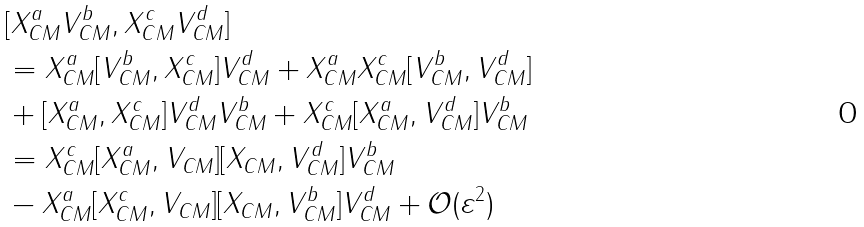Convert formula to latex. <formula><loc_0><loc_0><loc_500><loc_500>& [ X _ { C M } ^ { a } V _ { C M } ^ { b } , X _ { C M } ^ { c } V _ { C M } ^ { d } ] \\ & = X _ { C M } ^ { a } [ V _ { C M } ^ { b } , X _ { C M } ^ { c } ] V _ { C M } ^ { d } + X _ { C M } ^ { a } X _ { C M } ^ { c } [ V _ { C M } ^ { b } , V _ { C M } ^ { d } ] \\ & + [ X _ { C M } ^ { a } , X _ { C M } ^ { c } ] V _ { C M } ^ { d } V _ { C M } ^ { b } + X _ { C M } ^ { c } [ X _ { C M } ^ { a } , V _ { C M } ^ { d } ] V _ { C M } ^ { b } \\ & = X _ { C M } ^ { c } [ X _ { C M } ^ { a } , V _ { C M } ] [ X _ { C M } , V _ { C M } ^ { d } ] V _ { C M } ^ { b } \\ & - X _ { C M } ^ { a } [ X _ { C M } ^ { c } , V _ { C M } ] [ X _ { C M } , V _ { C M } ^ { b } ] V _ { C M } ^ { d } + \mathcal { O } ( \varepsilon ^ { 2 } )</formula> 